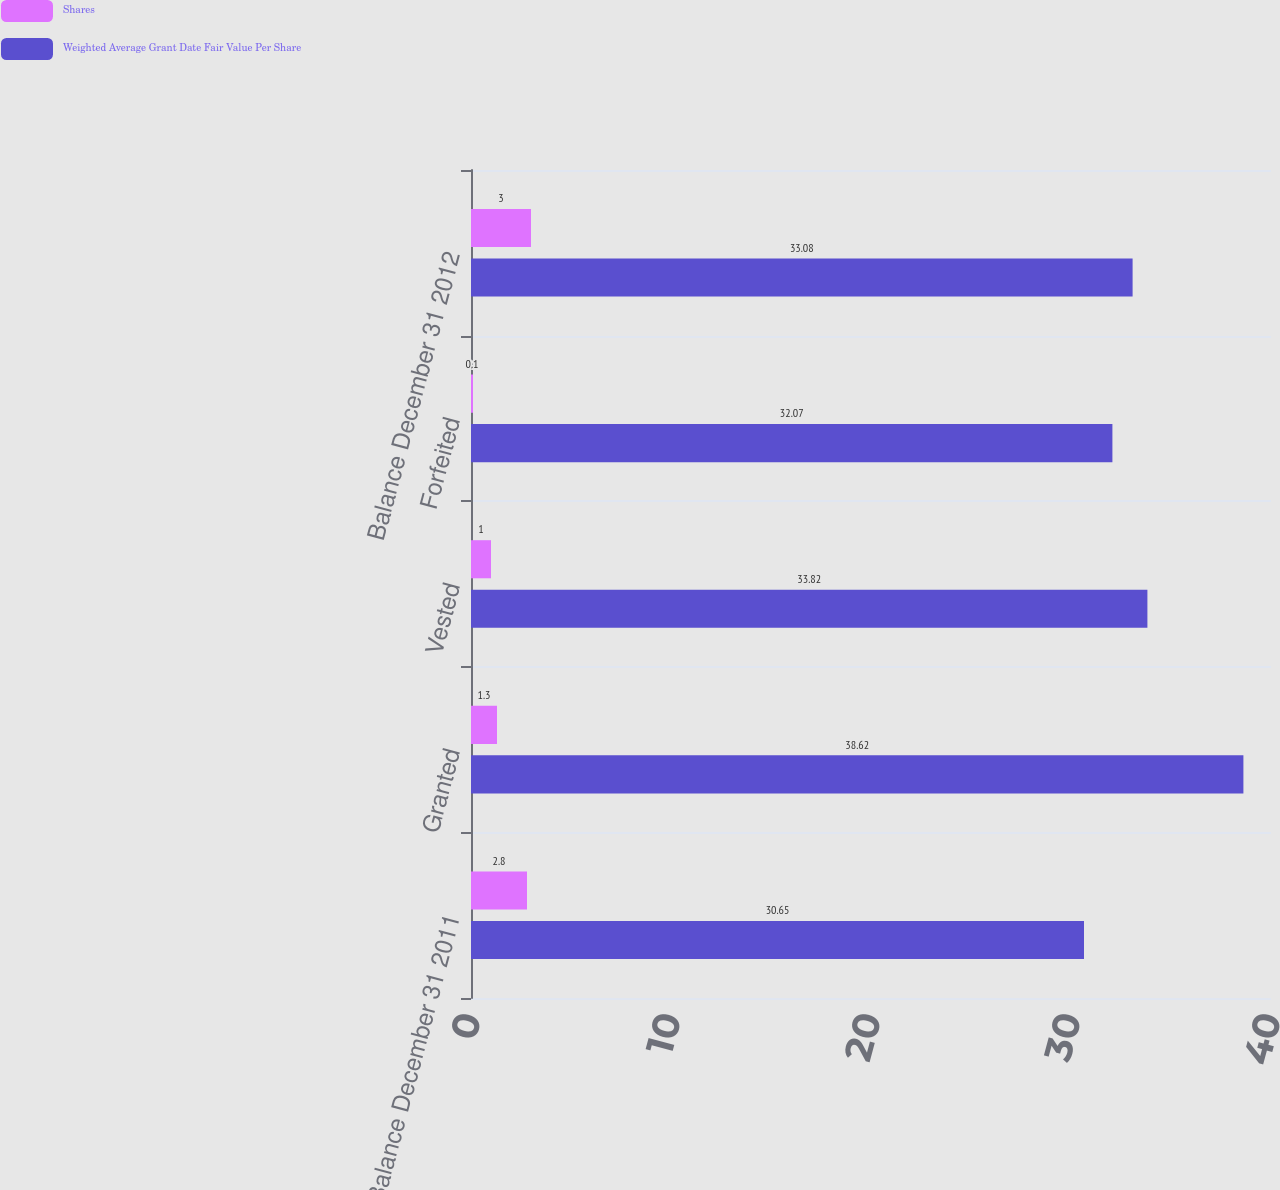Convert chart to OTSL. <chart><loc_0><loc_0><loc_500><loc_500><stacked_bar_chart><ecel><fcel>Balance December 31 2011<fcel>Granted<fcel>Vested<fcel>Forfeited<fcel>Balance December 31 2012<nl><fcel>Shares<fcel>2.8<fcel>1.3<fcel>1<fcel>0.1<fcel>3<nl><fcel>Weighted Average Grant Date Fair Value Per Share<fcel>30.65<fcel>38.62<fcel>33.82<fcel>32.07<fcel>33.08<nl></chart> 